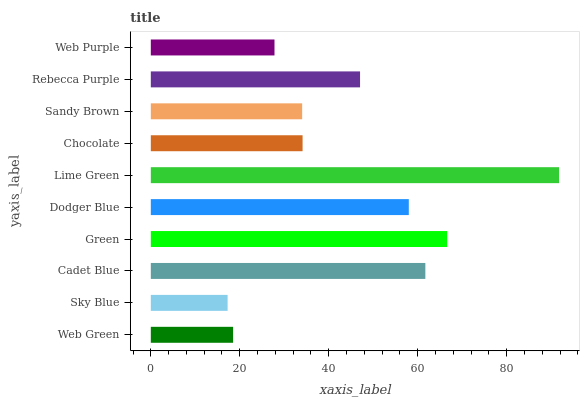Is Sky Blue the minimum?
Answer yes or no. Yes. Is Lime Green the maximum?
Answer yes or no. Yes. Is Cadet Blue the minimum?
Answer yes or no. No. Is Cadet Blue the maximum?
Answer yes or no. No. Is Cadet Blue greater than Sky Blue?
Answer yes or no. Yes. Is Sky Blue less than Cadet Blue?
Answer yes or no. Yes. Is Sky Blue greater than Cadet Blue?
Answer yes or no. No. Is Cadet Blue less than Sky Blue?
Answer yes or no. No. Is Rebecca Purple the high median?
Answer yes or no. Yes. Is Chocolate the low median?
Answer yes or no. Yes. Is Web Purple the high median?
Answer yes or no. No. Is Rebecca Purple the low median?
Answer yes or no. No. 